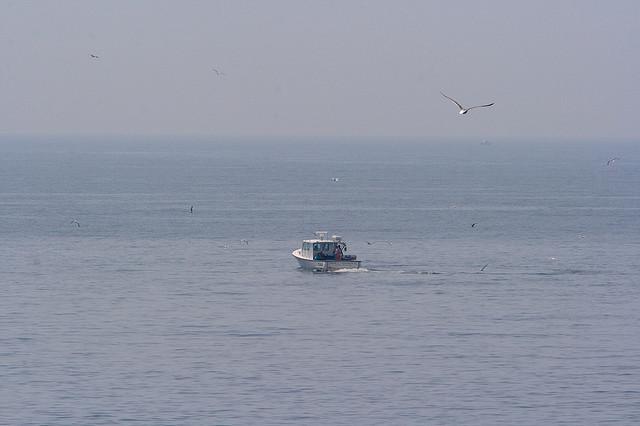Is this photo taken at night?
Quick response, please. No. Is this boat sinking?
Write a very short answer. No. Is there a bird flying above the boat?
Write a very short answer. Yes. Is this water calm?
Answer briefly. Yes. What sort of boats are in the background?
Give a very brief answer. Fishing. Who is in the water?
Short answer required. Boat. What color is the boat?
Answer briefly. White. Is it windy?
Be succinct. No. How many people are in the boat?
Write a very short answer. 2. What is the condition of the boat?
Short answer required. Good. How big is this ship?
Be succinct. Small. Is there any trees in the picture?
Keep it brief. No. What kind of boat is shown?
Short answer required. Fishing. Is the boat moving?
Concise answer only. Yes. Is there a boat?
Short answer required. Yes. Where is the bird?
Concise answer only. Sky. Are there more than three fish in that water?
Short answer required. Yes. Is this an overcast day?
Answer briefly. Yes. 